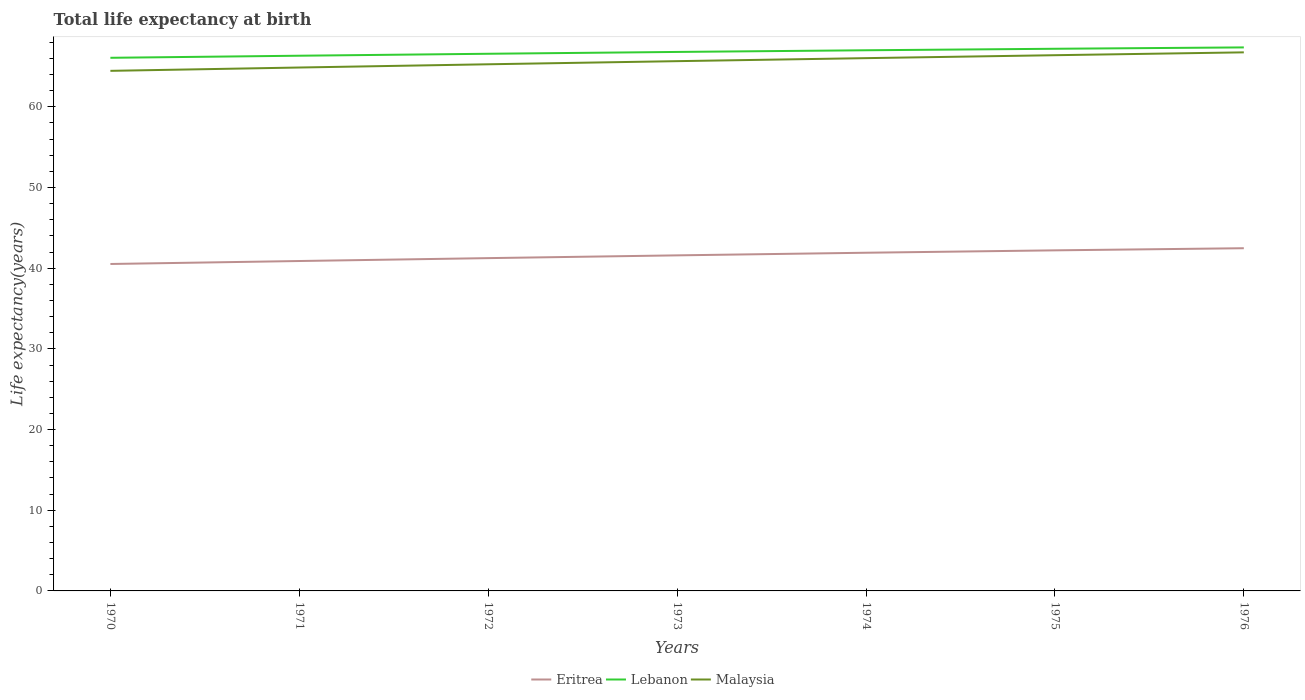How many different coloured lines are there?
Your answer should be compact. 3. Does the line corresponding to Lebanon intersect with the line corresponding to Malaysia?
Make the answer very short. No. Across all years, what is the maximum life expectancy at birth in in Lebanon?
Offer a terse response. 66.08. What is the total life expectancy at birth in in Lebanon in the graph?
Provide a succinct answer. -0.47. What is the difference between the highest and the second highest life expectancy at birth in in Lebanon?
Your answer should be compact. 1.29. What is the difference between the highest and the lowest life expectancy at birth in in Eritrea?
Your response must be concise. 4. Is the life expectancy at birth in in Malaysia strictly greater than the life expectancy at birth in in Eritrea over the years?
Make the answer very short. No. How many years are there in the graph?
Give a very brief answer. 7. What is the difference between two consecutive major ticks on the Y-axis?
Your response must be concise. 10. Are the values on the major ticks of Y-axis written in scientific E-notation?
Your response must be concise. No. Does the graph contain grids?
Provide a succinct answer. No. Where does the legend appear in the graph?
Give a very brief answer. Bottom center. What is the title of the graph?
Offer a very short reply. Total life expectancy at birth. What is the label or title of the Y-axis?
Offer a terse response. Life expectancy(years). What is the Life expectancy(years) in Eritrea in 1970?
Your response must be concise. 40.52. What is the Life expectancy(years) in Lebanon in 1970?
Make the answer very short. 66.08. What is the Life expectancy(years) of Malaysia in 1970?
Make the answer very short. 64.46. What is the Life expectancy(years) of Eritrea in 1971?
Offer a very short reply. 40.89. What is the Life expectancy(years) of Lebanon in 1971?
Offer a very short reply. 66.34. What is the Life expectancy(years) of Malaysia in 1971?
Ensure brevity in your answer.  64.88. What is the Life expectancy(years) of Eritrea in 1972?
Ensure brevity in your answer.  41.25. What is the Life expectancy(years) in Lebanon in 1972?
Keep it short and to the point. 66.58. What is the Life expectancy(years) of Malaysia in 1972?
Make the answer very short. 65.28. What is the Life expectancy(years) of Eritrea in 1973?
Your response must be concise. 41.59. What is the Life expectancy(years) of Lebanon in 1973?
Make the answer very short. 66.81. What is the Life expectancy(years) of Malaysia in 1973?
Make the answer very short. 65.66. What is the Life expectancy(years) of Eritrea in 1974?
Ensure brevity in your answer.  41.92. What is the Life expectancy(years) of Lebanon in 1974?
Make the answer very short. 67.01. What is the Life expectancy(years) of Malaysia in 1974?
Ensure brevity in your answer.  66.04. What is the Life expectancy(years) in Eritrea in 1975?
Provide a succinct answer. 42.21. What is the Life expectancy(years) of Lebanon in 1975?
Your answer should be compact. 67.2. What is the Life expectancy(years) of Malaysia in 1975?
Offer a terse response. 66.4. What is the Life expectancy(years) of Eritrea in 1976?
Make the answer very short. 42.48. What is the Life expectancy(years) in Lebanon in 1976?
Your response must be concise. 67.37. What is the Life expectancy(years) in Malaysia in 1976?
Keep it short and to the point. 66.75. Across all years, what is the maximum Life expectancy(years) in Eritrea?
Offer a very short reply. 42.48. Across all years, what is the maximum Life expectancy(years) in Lebanon?
Your answer should be compact. 67.37. Across all years, what is the maximum Life expectancy(years) of Malaysia?
Ensure brevity in your answer.  66.75. Across all years, what is the minimum Life expectancy(years) in Eritrea?
Your answer should be very brief. 40.52. Across all years, what is the minimum Life expectancy(years) of Lebanon?
Make the answer very short. 66.08. Across all years, what is the minimum Life expectancy(years) in Malaysia?
Offer a very short reply. 64.46. What is the total Life expectancy(years) in Eritrea in the graph?
Provide a short and direct response. 290.86. What is the total Life expectancy(years) of Lebanon in the graph?
Your response must be concise. 467.38. What is the total Life expectancy(years) in Malaysia in the graph?
Provide a succinct answer. 459.47. What is the difference between the Life expectancy(years) of Eritrea in 1970 and that in 1971?
Your answer should be very brief. -0.37. What is the difference between the Life expectancy(years) of Lebanon in 1970 and that in 1971?
Your answer should be very brief. -0.26. What is the difference between the Life expectancy(years) in Malaysia in 1970 and that in 1971?
Offer a terse response. -0.41. What is the difference between the Life expectancy(years) in Eritrea in 1970 and that in 1972?
Ensure brevity in your answer.  -0.73. What is the difference between the Life expectancy(years) of Lebanon in 1970 and that in 1972?
Offer a very short reply. -0.5. What is the difference between the Life expectancy(years) of Malaysia in 1970 and that in 1972?
Keep it short and to the point. -0.81. What is the difference between the Life expectancy(years) of Eritrea in 1970 and that in 1973?
Give a very brief answer. -1.07. What is the difference between the Life expectancy(years) in Lebanon in 1970 and that in 1973?
Offer a terse response. -0.73. What is the difference between the Life expectancy(years) of Malaysia in 1970 and that in 1973?
Offer a terse response. -1.2. What is the difference between the Life expectancy(years) of Eritrea in 1970 and that in 1974?
Provide a short and direct response. -1.39. What is the difference between the Life expectancy(years) of Lebanon in 1970 and that in 1974?
Keep it short and to the point. -0.93. What is the difference between the Life expectancy(years) in Malaysia in 1970 and that in 1974?
Your answer should be compact. -1.57. What is the difference between the Life expectancy(years) in Eritrea in 1970 and that in 1975?
Your answer should be very brief. -1.69. What is the difference between the Life expectancy(years) in Lebanon in 1970 and that in 1975?
Give a very brief answer. -1.12. What is the difference between the Life expectancy(years) of Malaysia in 1970 and that in 1975?
Your response must be concise. -1.94. What is the difference between the Life expectancy(years) in Eritrea in 1970 and that in 1976?
Make the answer very short. -1.95. What is the difference between the Life expectancy(years) in Lebanon in 1970 and that in 1976?
Your answer should be compact. -1.29. What is the difference between the Life expectancy(years) of Malaysia in 1970 and that in 1976?
Offer a terse response. -2.29. What is the difference between the Life expectancy(years) in Eritrea in 1971 and that in 1972?
Offer a terse response. -0.36. What is the difference between the Life expectancy(years) in Lebanon in 1971 and that in 1972?
Make the answer very short. -0.24. What is the difference between the Life expectancy(years) in Malaysia in 1971 and that in 1972?
Ensure brevity in your answer.  -0.4. What is the difference between the Life expectancy(years) of Eritrea in 1971 and that in 1973?
Your response must be concise. -0.7. What is the difference between the Life expectancy(years) in Lebanon in 1971 and that in 1973?
Make the answer very short. -0.47. What is the difference between the Life expectancy(years) in Malaysia in 1971 and that in 1973?
Make the answer very short. -0.79. What is the difference between the Life expectancy(years) of Eritrea in 1971 and that in 1974?
Give a very brief answer. -1.03. What is the difference between the Life expectancy(years) of Lebanon in 1971 and that in 1974?
Make the answer very short. -0.68. What is the difference between the Life expectancy(years) of Malaysia in 1971 and that in 1974?
Provide a short and direct response. -1.16. What is the difference between the Life expectancy(years) of Eritrea in 1971 and that in 1975?
Your answer should be compact. -1.32. What is the difference between the Life expectancy(years) of Lebanon in 1971 and that in 1975?
Your answer should be compact. -0.86. What is the difference between the Life expectancy(years) of Malaysia in 1971 and that in 1975?
Your answer should be compact. -1.53. What is the difference between the Life expectancy(years) of Eritrea in 1971 and that in 1976?
Your response must be concise. -1.59. What is the difference between the Life expectancy(years) in Lebanon in 1971 and that in 1976?
Ensure brevity in your answer.  -1.03. What is the difference between the Life expectancy(years) in Malaysia in 1971 and that in 1976?
Make the answer very short. -1.88. What is the difference between the Life expectancy(years) of Eritrea in 1972 and that in 1973?
Your answer should be compact. -0.34. What is the difference between the Life expectancy(years) in Lebanon in 1972 and that in 1973?
Provide a succinct answer. -0.23. What is the difference between the Life expectancy(years) of Malaysia in 1972 and that in 1973?
Make the answer very short. -0.39. What is the difference between the Life expectancy(years) in Eritrea in 1972 and that in 1974?
Offer a terse response. -0.67. What is the difference between the Life expectancy(years) of Lebanon in 1972 and that in 1974?
Offer a very short reply. -0.43. What is the difference between the Life expectancy(years) of Malaysia in 1972 and that in 1974?
Your response must be concise. -0.76. What is the difference between the Life expectancy(years) of Eritrea in 1972 and that in 1975?
Make the answer very short. -0.97. What is the difference between the Life expectancy(years) of Lebanon in 1972 and that in 1975?
Keep it short and to the point. -0.62. What is the difference between the Life expectancy(years) of Malaysia in 1972 and that in 1975?
Offer a terse response. -1.13. What is the difference between the Life expectancy(years) in Eritrea in 1972 and that in 1976?
Provide a succinct answer. -1.23. What is the difference between the Life expectancy(years) in Lebanon in 1972 and that in 1976?
Your answer should be compact. -0.79. What is the difference between the Life expectancy(years) of Malaysia in 1972 and that in 1976?
Your answer should be compact. -1.48. What is the difference between the Life expectancy(years) in Eritrea in 1973 and that in 1974?
Keep it short and to the point. -0.32. What is the difference between the Life expectancy(years) in Lebanon in 1973 and that in 1974?
Your answer should be very brief. -0.21. What is the difference between the Life expectancy(years) in Malaysia in 1973 and that in 1974?
Your answer should be very brief. -0.38. What is the difference between the Life expectancy(years) in Eritrea in 1973 and that in 1975?
Give a very brief answer. -0.62. What is the difference between the Life expectancy(years) in Lebanon in 1973 and that in 1975?
Give a very brief answer. -0.39. What is the difference between the Life expectancy(years) of Malaysia in 1973 and that in 1975?
Your answer should be very brief. -0.74. What is the difference between the Life expectancy(years) of Eritrea in 1973 and that in 1976?
Provide a succinct answer. -0.88. What is the difference between the Life expectancy(years) in Lebanon in 1973 and that in 1976?
Offer a very short reply. -0.56. What is the difference between the Life expectancy(years) of Malaysia in 1973 and that in 1976?
Your response must be concise. -1.09. What is the difference between the Life expectancy(years) of Eritrea in 1974 and that in 1975?
Provide a succinct answer. -0.3. What is the difference between the Life expectancy(years) of Lebanon in 1974 and that in 1975?
Keep it short and to the point. -0.19. What is the difference between the Life expectancy(years) of Malaysia in 1974 and that in 1975?
Your response must be concise. -0.36. What is the difference between the Life expectancy(years) of Eritrea in 1974 and that in 1976?
Your answer should be very brief. -0.56. What is the difference between the Life expectancy(years) of Lebanon in 1974 and that in 1976?
Provide a succinct answer. -0.36. What is the difference between the Life expectancy(years) in Malaysia in 1974 and that in 1976?
Your answer should be compact. -0.72. What is the difference between the Life expectancy(years) of Eritrea in 1975 and that in 1976?
Keep it short and to the point. -0.26. What is the difference between the Life expectancy(years) in Lebanon in 1975 and that in 1976?
Provide a succinct answer. -0.17. What is the difference between the Life expectancy(years) of Malaysia in 1975 and that in 1976?
Offer a terse response. -0.35. What is the difference between the Life expectancy(years) of Eritrea in 1970 and the Life expectancy(years) of Lebanon in 1971?
Your response must be concise. -25.81. What is the difference between the Life expectancy(years) of Eritrea in 1970 and the Life expectancy(years) of Malaysia in 1971?
Your answer should be compact. -24.35. What is the difference between the Life expectancy(years) of Lebanon in 1970 and the Life expectancy(years) of Malaysia in 1971?
Make the answer very short. 1.2. What is the difference between the Life expectancy(years) of Eritrea in 1970 and the Life expectancy(years) of Lebanon in 1972?
Offer a very short reply. -26.06. What is the difference between the Life expectancy(years) in Eritrea in 1970 and the Life expectancy(years) in Malaysia in 1972?
Offer a terse response. -24.75. What is the difference between the Life expectancy(years) in Lebanon in 1970 and the Life expectancy(years) in Malaysia in 1972?
Keep it short and to the point. 0.8. What is the difference between the Life expectancy(years) of Eritrea in 1970 and the Life expectancy(years) of Lebanon in 1973?
Offer a very short reply. -26.28. What is the difference between the Life expectancy(years) of Eritrea in 1970 and the Life expectancy(years) of Malaysia in 1973?
Your answer should be very brief. -25.14. What is the difference between the Life expectancy(years) of Lebanon in 1970 and the Life expectancy(years) of Malaysia in 1973?
Your response must be concise. 0.42. What is the difference between the Life expectancy(years) in Eritrea in 1970 and the Life expectancy(years) in Lebanon in 1974?
Offer a very short reply. -26.49. What is the difference between the Life expectancy(years) in Eritrea in 1970 and the Life expectancy(years) in Malaysia in 1974?
Make the answer very short. -25.51. What is the difference between the Life expectancy(years) of Lebanon in 1970 and the Life expectancy(years) of Malaysia in 1974?
Give a very brief answer. 0.04. What is the difference between the Life expectancy(years) in Eritrea in 1970 and the Life expectancy(years) in Lebanon in 1975?
Offer a very short reply. -26.68. What is the difference between the Life expectancy(years) in Eritrea in 1970 and the Life expectancy(years) in Malaysia in 1975?
Your answer should be very brief. -25.88. What is the difference between the Life expectancy(years) of Lebanon in 1970 and the Life expectancy(years) of Malaysia in 1975?
Give a very brief answer. -0.32. What is the difference between the Life expectancy(years) of Eritrea in 1970 and the Life expectancy(years) of Lebanon in 1976?
Ensure brevity in your answer.  -26.84. What is the difference between the Life expectancy(years) of Eritrea in 1970 and the Life expectancy(years) of Malaysia in 1976?
Offer a terse response. -26.23. What is the difference between the Life expectancy(years) of Lebanon in 1970 and the Life expectancy(years) of Malaysia in 1976?
Offer a terse response. -0.68. What is the difference between the Life expectancy(years) in Eritrea in 1971 and the Life expectancy(years) in Lebanon in 1972?
Your answer should be compact. -25.69. What is the difference between the Life expectancy(years) in Eritrea in 1971 and the Life expectancy(years) in Malaysia in 1972?
Make the answer very short. -24.38. What is the difference between the Life expectancy(years) in Lebanon in 1971 and the Life expectancy(years) in Malaysia in 1972?
Ensure brevity in your answer.  1.06. What is the difference between the Life expectancy(years) of Eritrea in 1971 and the Life expectancy(years) of Lebanon in 1973?
Provide a succinct answer. -25.91. What is the difference between the Life expectancy(years) in Eritrea in 1971 and the Life expectancy(years) in Malaysia in 1973?
Ensure brevity in your answer.  -24.77. What is the difference between the Life expectancy(years) in Lebanon in 1971 and the Life expectancy(years) in Malaysia in 1973?
Ensure brevity in your answer.  0.67. What is the difference between the Life expectancy(years) of Eritrea in 1971 and the Life expectancy(years) of Lebanon in 1974?
Offer a terse response. -26.12. What is the difference between the Life expectancy(years) of Eritrea in 1971 and the Life expectancy(years) of Malaysia in 1974?
Offer a terse response. -25.15. What is the difference between the Life expectancy(years) in Lebanon in 1971 and the Life expectancy(years) in Malaysia in 1974?
Offer a very short reply. 0.3. What is the difference between the Life expectancy(years) in Eritrea in 1971 and the Life expectancy(years) in Lebanon in 1975?
Offer a terse response. -26.31. What is the difference between the Life expectancy(years) of Eritrea in 1971 and the Life expectancy(years) of Malaysia in 1975?
Your answer should be very brief. -25.51. What is the difference between the Life expectancy(years) of Lebanon in 1971 and the Life expectancy(years) of Malaysia in 1975?
Make the answer very short. -0.06. What is the difference between the Life expectancy(years) of Eritrea in 1971 and the Life expectancy(years) of Lebanon in 1976?
Ensure brevity in your answer.  -26.48. What is the difference between the Life expectancy(years) in Eritrea in 1971 and the Life expectancy(years) in Malaysia in 1976?
Your answer should be compact. -25.86. What is the difference between the Life expectancy(years) of Lebanon in 1971 and the Life expectancy(years) of Malaysia in 1976?
Your answer should be very brief. -0.42. What is the difference between the Life expectancy(years) in Eritrea in 1972 and the Life expectancy(years) in Lebanon in 1973?
Offer a very short reply. -25.56. What is the difference between the Life expectancy(years) of Eritrea in 1972 and the Life expectancy(years) of Malaysia in 1973?
Give a very brief answer. -24.41. What is the difference between the Life expectancy(years) of Lebanon in 1972 and the Life expectancy(years) of Malaysia in 1973?
Give a very brief answer. 0.92. What is the difference between the Life expectancy(years) in Eritrea in 1972 and the Life expectancy(years) in Lebanon in 1974?
Ensure brevity in your answer.  -25.76. What is the difference between the Life expectancy(years) in Eritrea in 1972 and the Life expectancy(years) in Malaysia in 1974?
Offer a terse response. -24.79. What is the difference between the Life expectancy(years) in Lebanon in 1972 and the Life expectancy(years) in Malaysia in 1974?
Provide a succinct answer. 0.54. What is the difference between the Life expectancy(years) of Eritrea in 1972 and the Life expectancy(years) of Lebanon in 1975?
Your response must be concise. -25.95. What is the difference between the Life expectancy(years) in Eritrea in 1972 and the Life expectancy(years) in Malaysia in 1975?
Keep it short and to the point. -25.15. What is the difference between the Life expectancy(years) of Lebanon in 1972 and the Life expectancy(years) of Malaysia in 1975?
Offer a very short reply. 0.18. What is the difference between the Life expectancy(years) of Eritrea in 1972 and the Life expectancy(years) of Lebanon in 1976?
Your response must be concise. -26.12. What is the difference between the Life expectancy(years) in Eritrea in 1972 and the Life expectancy(years) in Malaysia in 1976?
Offer a terse response. -25.51. What is the difference between the Life expectancy(years) of Lebanon in 1972 and the Life expectancy(years) of Malaysia in 1976?
Make the answer very short. -0.17. What is the difference between the Life expectancy(years) of Eritrea in 1973 and the Life expectancy(years) of Lebanon in 1974?
Ensure brevity in your answer.  -25.42. What is the difference between the Life expectancy(years) of Eritrea in 1973 and the Life expectancy(years) of Malaysia in 1974?
Give a very brief answer. -24.45. What is the difference between the Life expectancy(years) of Lebanon in 1973 and the Life expectancy(years) of Malaysia in 1974?
Provide a short and direct response. 0.77. What is the difference between the Life expectancy(years) of Eritrea in 1973 and the Life expectancy(years) of Lebanon in 1975?
Keep it short and to the point. -25.61. What is the difference between the Life expectancy(years) of Eritrea in 1973 and the Life expectancy(years) of Malaysia in 1975?
Your response must be concise. -24.81. What is the difference between the Life expectancy(years) in Lebanon in 1973 and the Life expectancy(years) in Malaysia in 1975?
Provide a succinct answer. 0.4. What is the difference between the Life expectancy(years) of Eritrea in 1973 and the Life expectancy(years) of Lebanon in 1976?
Provide a short and direct response. -25.78. What is the difference between the Life expectancy(years) in Eritrea in 1973 and the Life expectancy(years) in Malaysia in 1976?
Make the answer very short. -25.16. What is the difference between the Life expectancy(years) in Lebanon in 1973 and the Life expectancy(years) in Malaysia in 1976?
Make the answer very short. 0.05. What is the difference between the Life expectancy(years) of Eritrea in 1974 and the Life expectancy(years) of Lebanon in 1975?
Make the answer very short. -25.28. What is the difference between the Life expectancy(years) in Eritrea in 1974 and the Life expectancy(years) in Malaysia in 1975?
Keep it short and to the point. -24.48. What is the difference between the Life expectancy(years) of Lebanon in 1974 and the Life expectancy(years) of Malaysia in 1975?
Your answer should be compact. 0.61. What is the difference between the Life expectancy(years) of Eritrea in 1974 and the Life expectancy(years) of Lebanon in 1976?
Your response must be concise. -25.45. What is the difference between the Life expectancy(years) of Eritrea in 1974 and the Life expectancy(years) of Malaysia in 1976?
Ensure brevity in your answer.  -24.84. What is the difference between the Life expectancy(years) of Lebanon in 1974 and the Life expectancy(years) of Malaysia in 1976?
Ensure brevity in your answer.  0.26. What is the difference between the Life expectancy(years) of Eritrea in 1975 and the Life expectancy(years) of Lebanon in 1976?
Provide a succinct answer. -25.15. What is the difference between the Life expectancy(years) of Eritrea in 1975 and the Life expectancy(years) of Malaysia in 1976?
Offer a terse response. -24.54. What is the difference between the Life expectancy(years) of Lebanon in 1975 and the Life expectancy(years) of Malaysia in 1976?
Offer a very short reply. 0.45. What is the average Life expectancy(years) in Eritrea per year?
Give a very brief answer. 41.55. What is the average Life expectancy(years) of Lebanon per year?
Give a very brief answer. 66.77. What is the average Life expectancy(years) of Malaysia per year?
Your answer should be very brief. 65.64. In the year 1970, what is the difference between the Life expectancy(years) of Eritrea and Life expectancy(years) of Lebanon?
Offer a very short reply. -25.56. In the year 1970, what is the difference between the Life expectancy(years) of Eritrea and Life expectancy(years) of Malaysia?
Offer a very short reply. -23.94. In the year 1970, what is the difference between the Life expectancy(years) in Lebanon and Life expectancy(years) in Malaysia?
Provide a succinct answer. 1.62. In the year 1971, what is the difference between the Life expectancy(years) of Eritrea and Life expectancy(years) of Lebanon?
Keep it short and to the point. -25.45. In the year 1971, what is the difference between the Life expectancy(years) in Eritrea and Life expectancy(years) in Malaysia?
Give a very brief answer. -23.98. In the year 1971, what is the difference between the Life expectancy(years) of Lebanon and Life expectancy(years) of Malaysia?
Provide a succinct answer. 1.46. In the year 1972, what is the difference between the Life expectancy(years) in Eritrea and Life expectancy(years) in Lebanon?
Your answer should be compact. -25.33. In the year 1972, what is the difference between the Life expectancy(years) in Eritrea and Life expectancy(years) in Malaysia?
Offer a very short reply. -24.03. In the year 1972, what is the difference between the Life expectancy(years) in Lebanon and Life expectancy(years) in Malaysia?
Make the answer very short. 1.3. In the year 1973, what is the difference between the Life expectancy(years) of Eritrea and Life expectancy(years) of Lebanon?
Offer a very short reply. -25.21. In the year 1973, what is the difference between the Life expectancy(years) in Eritrea and Life expectancy(years) in Malaysia?
Provide a succinct answer. -24.07. In the year 1973, what is the difference between the Life expectancy(years) of Lebanon and Life expectancy(years) of Malaysia?
Provide a short and direct response. 1.14. In the year 1974, what is the difference between the Life expectancy(years) in Eritrea and Life expectancy(years) in Lebanon?
Provide a short and direct response. -25.1. In the year 1974, what is the difference between the Life expectancy(years) in Eritrea and Life expectancy(years) in Malaysia?
Your answer should be very brief. -24.12. In the year 1974, what is the difference between the Life expectancy(years) of Lebanon and Life expectancy(years) of Malaysia?
Provide a short and direct response. 0.97. In the year 1975, what is the difference between the Life expectancy(years) in Eritrea and Life expectancy(years) in Lebanon?
Ensure brevity in your answer.  -24.98. In the year 1975, what is the difference between the Life expectancy(years) of Eritrea and Life expectancy(years) of Malaysia?
Offer a terse response. -24.19. In the year 1975, what is the difference between the Life expectancy(years) in Lebanon and Life expectancy(years) in Malaysia?
Provide a short and direct response. 0.8. In the year 1976, what is the difference between the Life expectancy(years) of Eritrea and Life expectancy(years) of Lebanon?
Provide a short and direct response. -24.89. In the year 1976, what is the difference between the Life expectancy(years) of Eritrea and Life expectancy(years) of Malaysia?
Provide a succinct answer. -24.28. In the year 1976, what is the difference between the Life expectancy(years) of Lebanon and Life expectancy(years) of Malaysia?
Give a very brief answer. 0.61. What is the ratio of the Life expectancy(years) of Malaysia in 1970 to that in 1971?
Give a very brief answer. 0.99. What is the ratio of the Life expectancy(years) in Eritrea in 1970 to that in 1972?
Your response must be concise. 0.98. What is the ratio of the Life expectancy(years) in Malaysia in 1970 to that in 1972?
Offer a very short reply. 0.99. What is the ratio of the Life expectancy(years) in Eritrea in 1970 to that in 1973?
Your response must be concise. 0.97. What is the ratio of the Life expectancy(years) of Malaysia in 1970 to that in 1973?
Provide a succinct answer. 0.98. What is the ratio of the Life expectancy(years) of Eritrea in 1970 to that in 1974?
Offer a very short reply. 0.97. What is the ratio of the Life expectancy(years) of Lebanon in 1970 to that in 1974?
Your answer should be compact. 0.99. What is the ratio of the Life expectancy(years) in Malaysia in 1970 to that in 1974?
Your answer should be very brief. 0.98. What is the ratio of the Life expectancy(years) in Eritrea in 1970 to that in 1975?
Make the answer very short. 0.96. What is the ratio of the Life expectancy(years) of Lebanon in 1970 to that in 1975?
Provide a short and direct response. 0.98. What is the ratio of the Life expectancy(years) of Malaysia in 1970 to that in 1975?
Ensure brevity in your answer.  0.97. What is the ratio of the Life expectancy(years) in Eritrea in 1970 to that in 1976?
Your response must be concise. 0.95. What is the ratio of the Life expectancy(years) of Lebanon in 1970 to that in 1976?
Your response must be concise. 0.98. What is the ratio of the Life expectancy(years) of Malaysia in 1970 to that in 1976?
Offer a terse response. 0.97. What is the ratio of the Life expectancy(years) in Malaysia in 1971 to that in 1972?
Offer a terse response. 0.99. What is the ratio of the Life expectancy(years) of Eritrea in 1971 to that in 1973?
Offer a terse response. 0.98. What is the ratio of the Life expectancy(years) in Lebanon in 1971 to that in 1973?
Offer a very short reply. 0.99. What is the ratio of the Life expectancy(years) of Malaysia in 1971 to that in 1973?
Offer a terse response. 0.99. What is the ratio of the Life expectancy(years) in Eritrea in 1971 to that in 1974?
Your answer should be very brief. 0.98. What is the ratio of the Life expectancy(years) of Malaysia in 1971 to that in 1974?
Offer a terse response. 0.98. What is the ratio of the Life expectancy(years) in Eritrea in 1971 to that in 1975?
Offer a very short reply. 0.97. What is the ratio of the Life expectancy(years) in Lebanon in 1971 to that in 1975?
Provide a short and direct response. 0.99. What is the ratio of the Life expectancy(years) in Malaysia in 1971 to that in 1975?
Offer a terse response. 0.98. What is the ratio of the Life expectancy(years) of Eritrea in 1971 to that in 1976?
Provide a short and direct response. 0.96. What is the ratio of the Life expectancy(years) of Lebanon in 1971 to that in 1976?
Your response must be concise. 0.98. What is the ratio of the Life expectancy(years) in Malaysia in 1971 to that in 1976?
Keep it short and to the point. 0.97. What is the ratio of the Life expectancy(years) in Lebanon in 1972 to that in 1973?
Provide a short and direct response. 1. What is the ratio of the Life expectancy(years) in Eritrea in 1972 to that in 1974?
Your response must be concise. 0.98. What is the ratio of the Life expectancy(years) of Lebanon in 1972 to that in 1974?
Your response must be concise. 0.99. What is the ratio of the Life expectancy(years) in Malaysia in 1972 to that in 1974?
Your response must be concise. 0.99. What is the ratio of the Life expectancy(years) of Eritrea in 1972 to that in 1975?
Ensure brevity in your answer.  0.98. What is the ratio of the Life expectancy(years) in Malaysia in 1972 to that in 1975?
Ensure brevity in your answer.  0.98. What is the ratio of the Life expectancy(years) of Eritrea in 1972 to that in 1976?
Provide a succinct answer. 0.97. What is the ratio of the Life expectancy(years) of Lebanon in 1972 to that in 1976?
Offer a very short reply. 0.99. What is the ratio of the Life expectancy(years) in Malaysia in 1972 to that in 1976?
Ensure brevity in your answer.  0.98. What is the ratio of the Life expectancy(years) in Eritrea in 1973 to that in 1974?
Provide a short and direct response. 0.99. What is the ratio of the Life expectancy(years) in Lebanon in 1973 to that in 1974?
Provide a short and direct response. 1. What is the ratio of the Life expectancy(years) of Lebanon in 1973 to that in 1975?
Provide a short and direct response. 0.99. What is the ratio of the Life expectancy(years) of Malaysia in 1973 to that in 1975?
Your answer should be very brief. 0.99. What is the ratio of the Life expectancy(years) in Eritrea in 1973 to that in 1976?
Your answer should be compact. 0.98. What is the ratio of the Life expectancy(years) in Malaysia in 1973 to that in 1976?
Give a very brief answer. 0.98. What is the ratio of the Life expectancy(years) in Eritrea in 1974 to that in 1975?
Make the answer very short. 0.99. What is the ratio of the Life expectancy(years) in Malaysia in 1974 to that in 1975?
Your answer should be compact. 0.99. What is the ratio of the Life expectancy(years) in Eritrea in 1974 to that in 1976?
Offer a terse response. 0.99. What is the ratio of the Life expectancy(years) of Lebanon in 1974 to that in 1976?
Your answer should be very brief. 0.99. What is the ratio of the Life expectancy(years) in Malaysia in 1974 to that in 1976?
Offer a terse response. 0.99. What is the ratio of the Life expectancy(years) in Lebanon in 1975 to that in 1976?
Your answer should be very brief. 1. What is the ratio of the Life expectancy(years) of Malaysia in 1975 to that in 1976?
Offer a terse response. 0.99. What is the difference between the highest and the second highest Life expectancy(years) in Eritrea?
Ensure brevity in your answer.  0.26. What is the difference between the highest and the second highest Life expectancy(years) of Lebanon?
Offer a terse response. 0.17. What is the difference between the highest and the second highest Life expectancy(years) of Malaysia?
Ensure brevity in your answer.  0.35. What is the difference between the highest and the lowest Life expectancy(years) of Eritrea?
Your response must be concise. 1.95. What is the difference between the highest and the lowest Life expectancy(years) of Lebanon?
Offer a very short reply. 1.29. What is the difference between the highest and the lowest Life expectancy(years) in Malaysia?
Offer a very short reply. 2.29. 